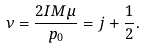Convert formula to latex. <formula><loc_0><loc_0><loc_500><loc_500>\nu = \frac { 2 I M \mu } { p _ { 0 } } = j + \frac { 1 } { 2 } .</formula> 